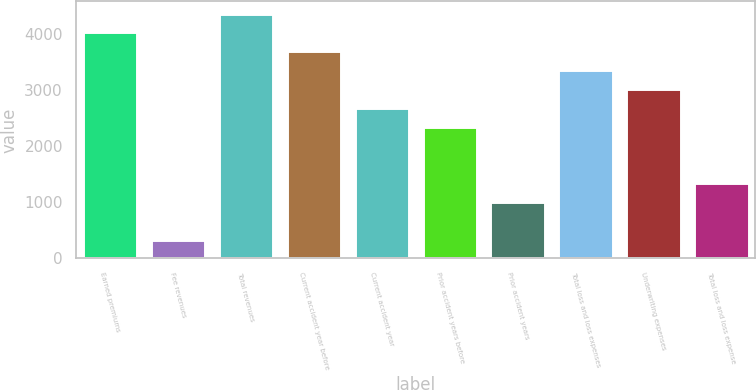Convert chart. <chart><loc_0><loc_0><loc_500><loc_500><bar_chart><fcel>Earned premiums<fcel>Fee revenues<fcel>Total revenues<fcel>Current accident year before<fcel>Current accident year<fcel>Prior accident years before<fcel>Prior accident years<fcel>Total loss and loss expenses<fcel>Underwriting expenses<fcel>Total loss and loss expense<nl><fcel>4019.86<fcel>335.63<fcel>4354.79<fcel>3684.93<fcel>2680.14<fcel>2345.21<fcel>1005.49<fcel>3350<fcel>3015.07<fcel>1340.42<nl></chart> 